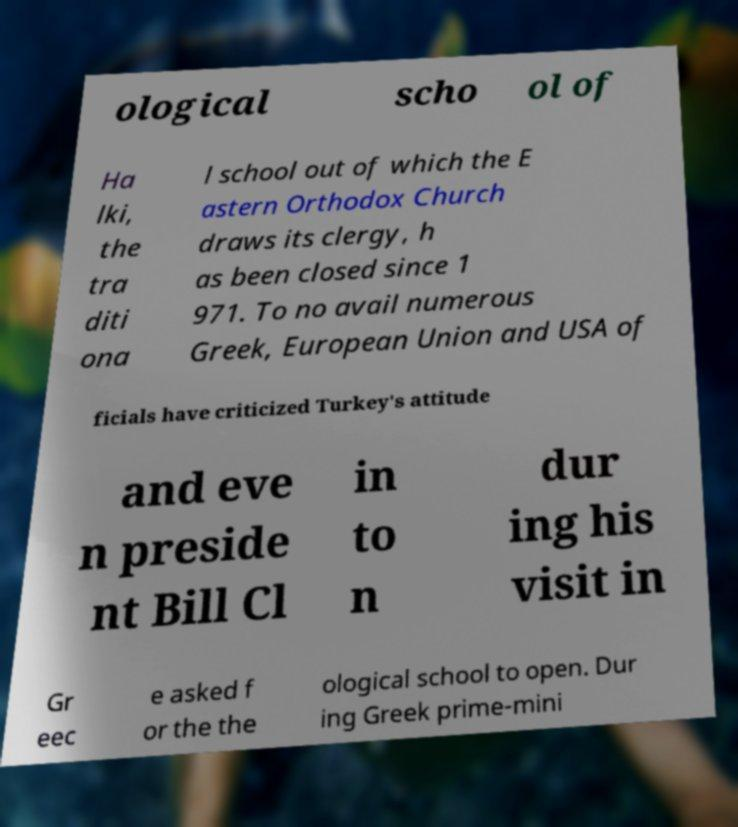For documentation purposes, I need the text within this image transcribed. Could you provide that? ological scho ol of Ha lki, the tra diti ona l school out of which the E astern Orthodox Church draws its clergy, h as been closed since 1 971. To no avail numerous Greek, European Union and USA of ficials have criticized Turkey's attitude and eve n preside nt Bill Cl in to n dur ing his visit in Gr eec e asked f or the the ological school to open. Dur ing Greek prime-mini 